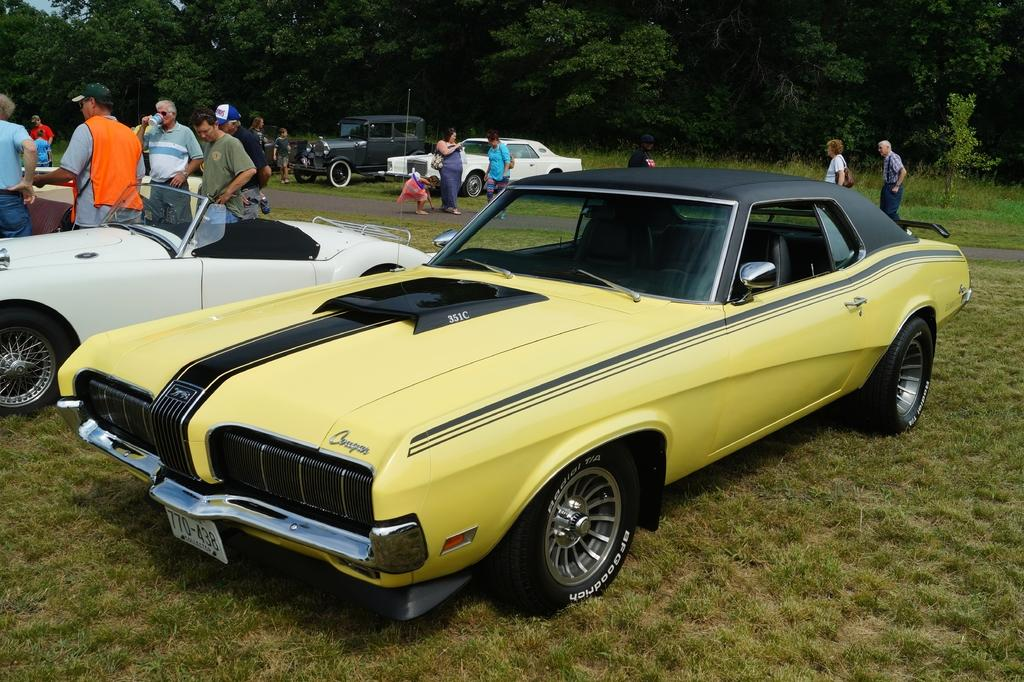What types of objects are present in the image? There are vehicles in the image. Can you describe one of the vehicles? One of the vehicles is yellow. What can be seen in the background of the image? There is a group of people standing in the background and trees. What is the color of the trees? The trees are green. What is the taste of the waves in the image? There are no waves present in the image, so it is not possible to determine their taste. 